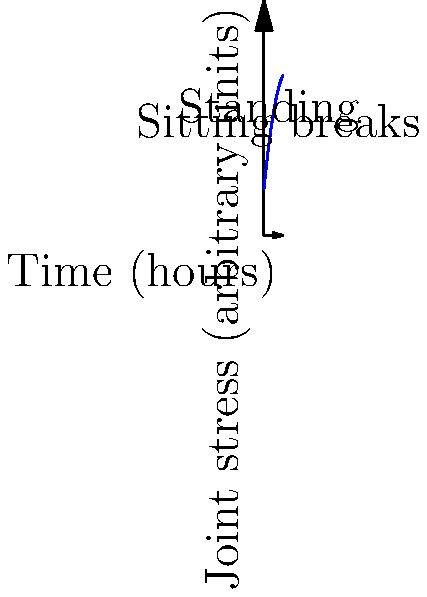Based on the graph showing joint stress over time for a teacher during a typical school day, at what point (in hours) does the biomechanical stress on the teacher's joints reach its maximum? How might this information be relevant to discussions about teacher working conditions and potential long-term health impacts in the context of the school-to-prison pipeline? To solve this problem, we need to follow these steps:

1. Analyze the graph: The curve represents joint stress over time for a teacher during a typical school day.

2. Identify the function: The graph appears to follow a quadratic function of the form $f(x) = ax^2 + bx + c$, where $x$ is time in hours and $f(x)$ is joint stress.

3. Find the maximum point: For a quadratic function, the maximum occurs at the vertex. The x-coordinate of the vertex can be found using the formula $x = -\frac{b}{2a}$.

4. Estimate values: From the graph, we can estimate that $a \approx -0.5$, $b \approx 10$, and $c \approx 20$.

5. Calculate the time of maximum stress:
   $x = -\frac{b}{2a} = -\frac{10}{2(-0.5)} = 10$ hours

6. Interpret the result: Since the graph only shows 8 hours, the maximum stress occurs at the end of the 8-hour period.

Relevance to the school-to-prison pipeline:
- Teacher working conditions, including physical stress, can impact the quality of education and teacher retention.
- Poor working conditions may lead to increased teacher turnover, particularly in underfunded schools.
- High teacher turnover and stressed teachers may contribute to a less supportive school environment, potentially exacerbating factors that contribute to the school-to-prison pipeline.
- Understanding these physical stressors could inform policies to improve teacher working conditions, potentially leading to better educational outcomes and reduced risk factors for the school-to-prison pipeline.
Answer: 8 hours 